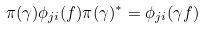Convert formula to latex. <formula><loc_0><loc_0><loc_500><loc_500>\pi ( \gamma ) \phi _ { j i } ( f ) \pi ( \gamma ) ^ { * } = \phi _ { j i } ( \gamma f )</formula> 